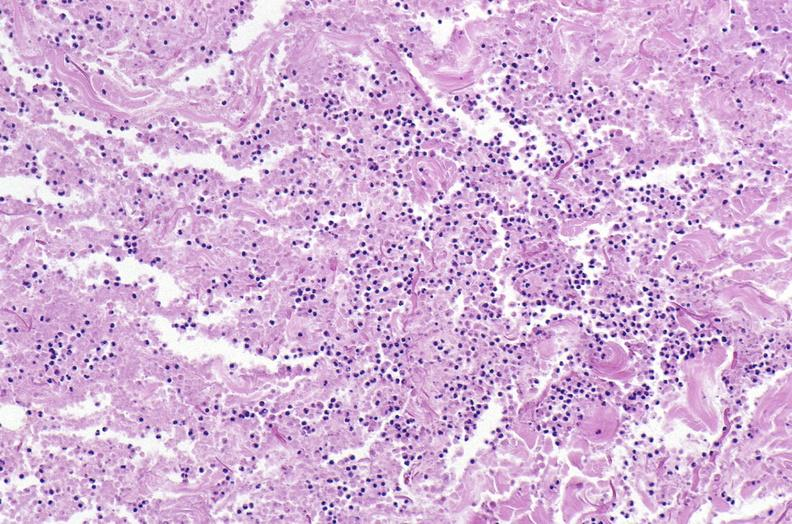does stillborn cord around neck show panniculitis and fascitis?
Answer the question using a single word or phrase. No 